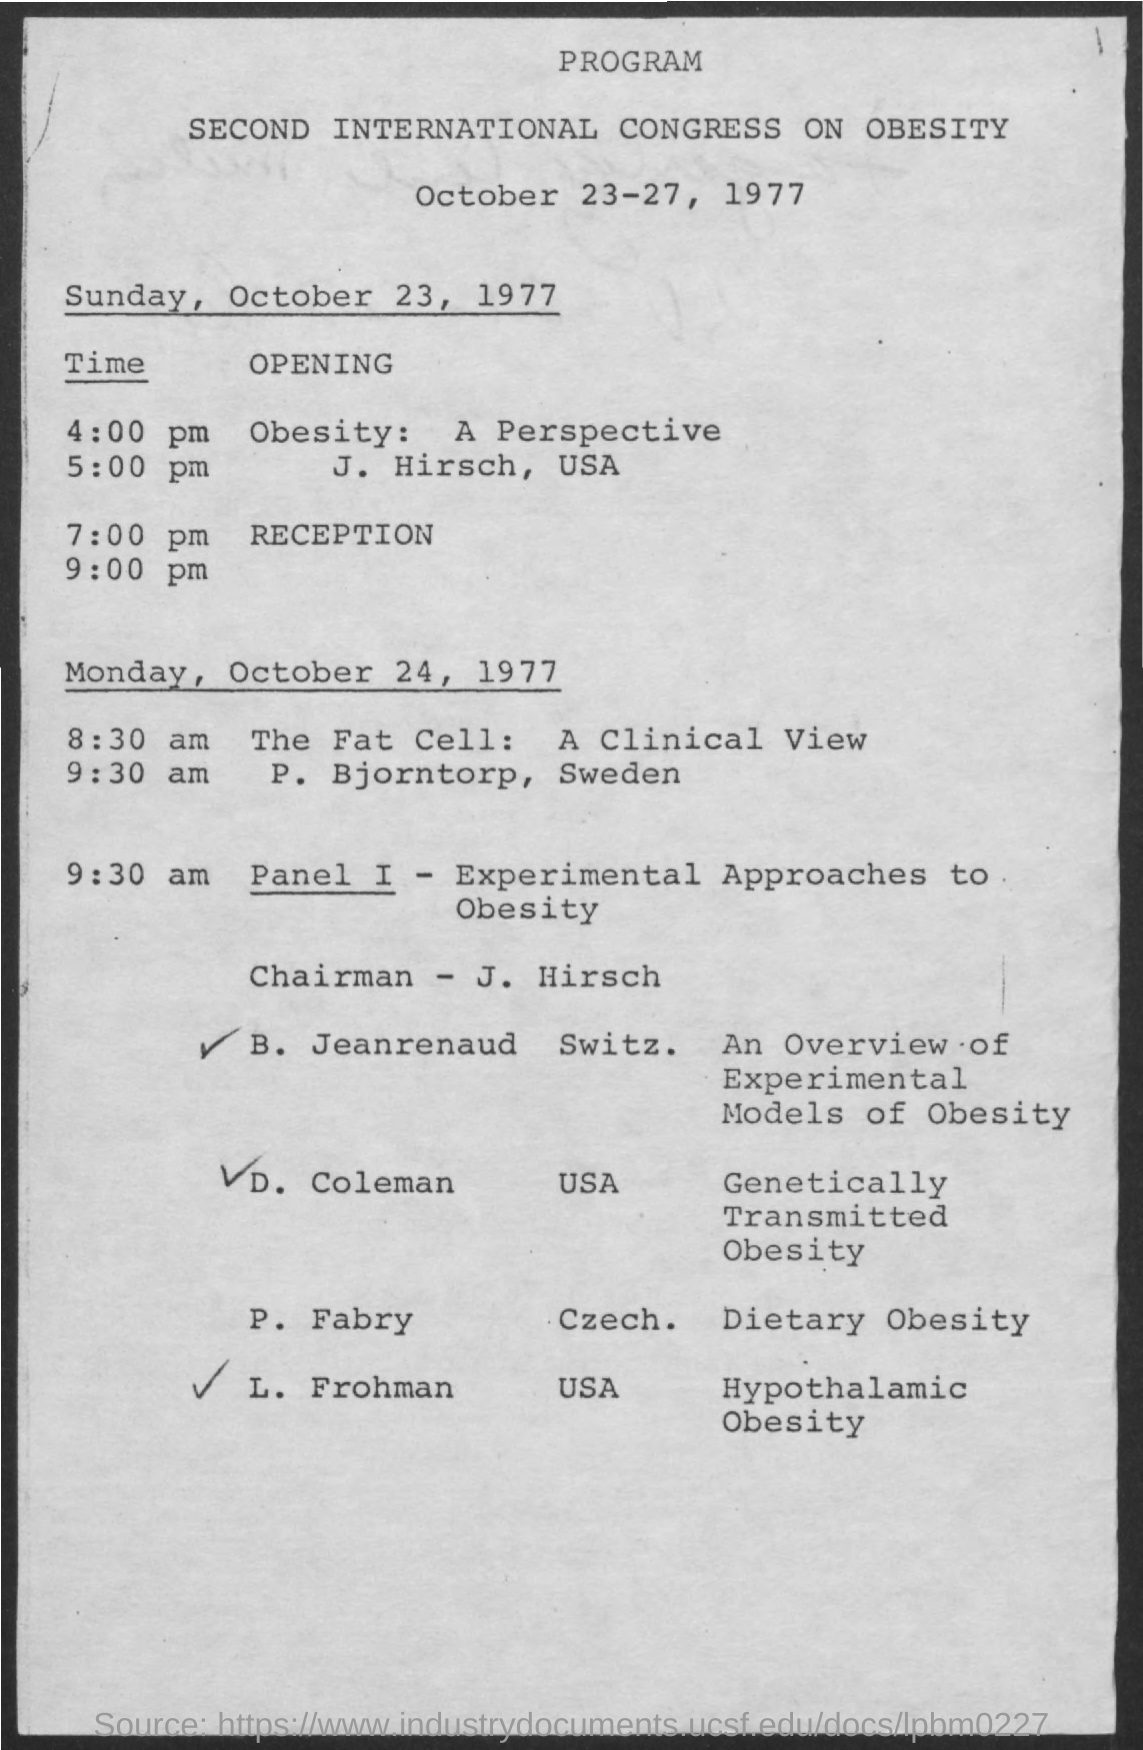who is the chairman ?
 J. Hirsch 